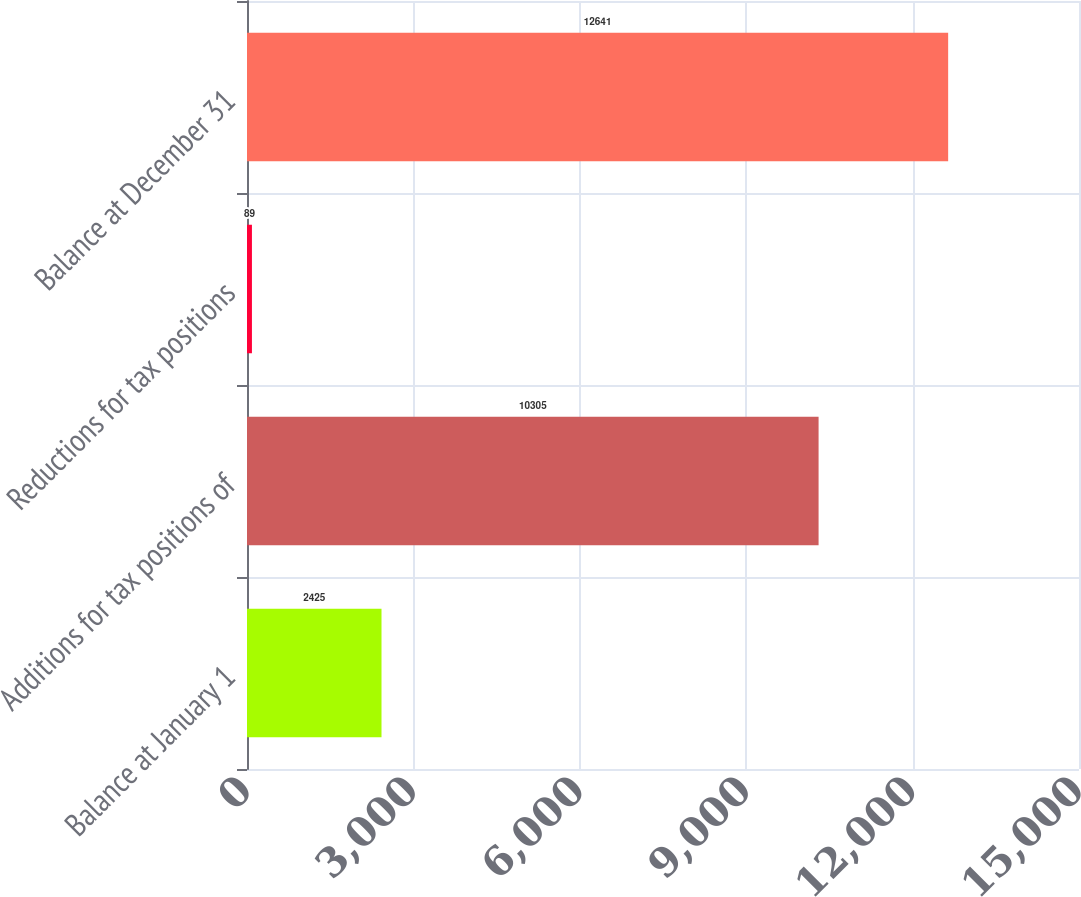Convert chart to OTSL. <chart><loc_0><loc_0><loc_500><loc_500><bar_chart><fcel>Balance at January 1<fcel>Additions for tax positions of<fcel>Reductions for tax positions<fcel>Balance at December 31<nl><fcel>2425<fcel>10305<fcel>89<fcel>12641<nl></chart> 